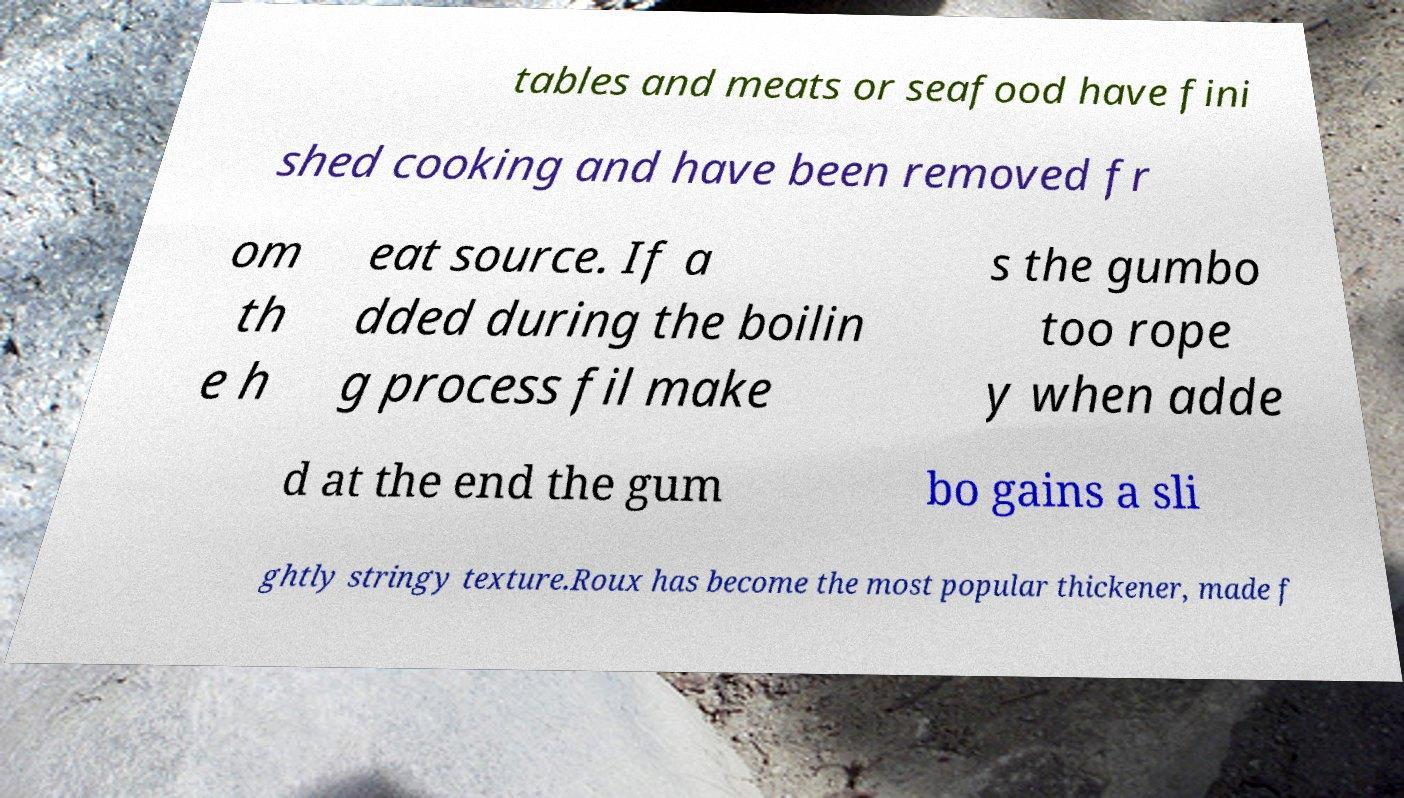For documentation purposes, I need the text within this image transcribed. Could you provide that? tables and meats or seafood have fini shed cooking and have been removed fr om th e h eat source. If a dded during the boilin g process fil make s the gumbo too rope y when adde d at the end the gum bo gains a sli ghtly stringy texture.Roux has become the most popular thickener, made f 